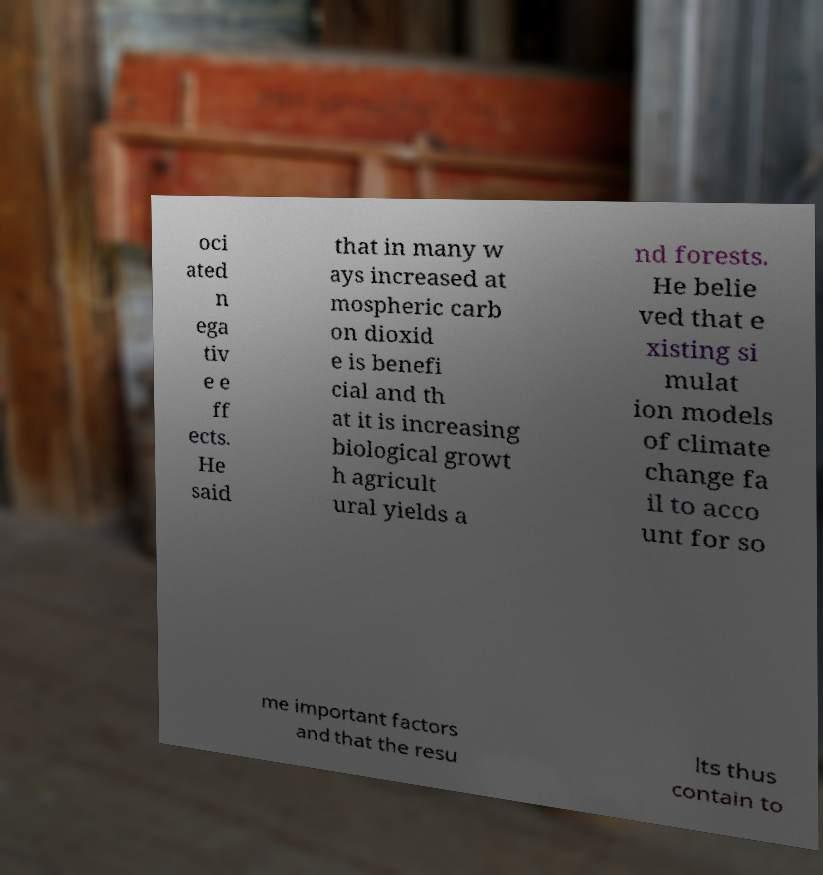Could you assist in decoding the text presented in this image and type it out clearly? oci ated n ega tiv e e ff ects. He said that in many w ays increased at mospheric carb on dioxid e is benefi cial and th at it is increasing biological growt h agricult ural yields a nd forests. He belie ved that e xisting si mulat ion models of climate change fa il to acco unt for so me important factors and that the resu lts thus contain to 